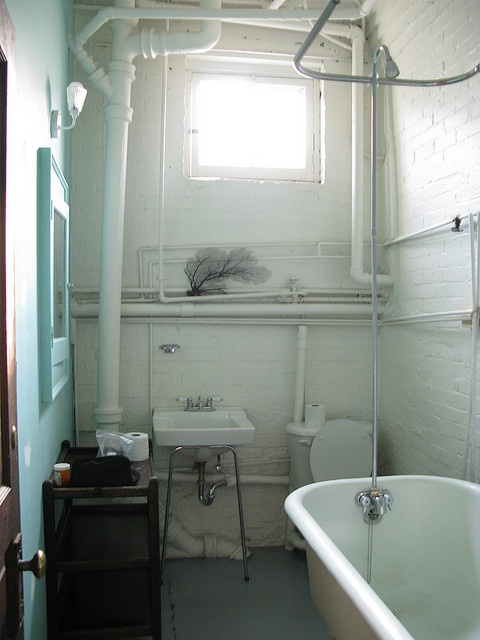Describe the objects in this image and their specific colors. I can see toilet in gray tones, sink in gray and darkgray tones, and handbag in gray, black, and purple tones in this image. 